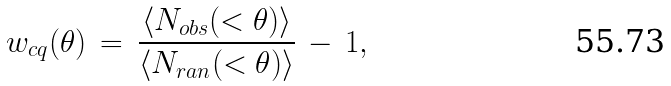Convert formula to latex. <formula><loc_0><loc_0><loc_500><loc_500>w _ { c q } ( \theta ) \, = \, \frac { \langle N _ { o b s } ( < \theta ) \rangle } { \langle N _ { r a n } ( < \theta ) \rangle } \, - \, 1 ,</formula> 